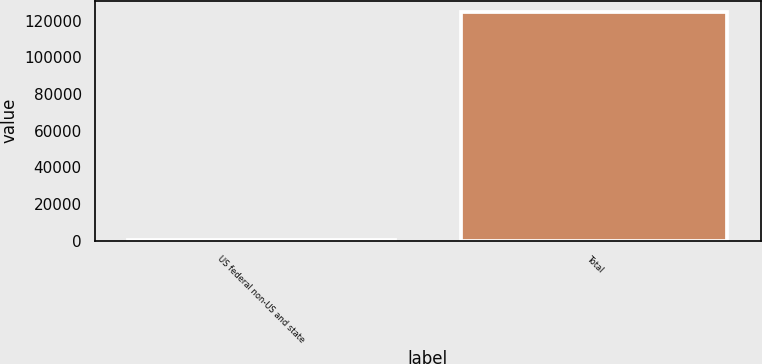Convert chart. <chart><loc_0><loc_0><loc_500><loc_500><bar_chart><fcel>US federal non-US and state<fcel>Total<nl><fcel>748<fcel>124712<nl></chart> 